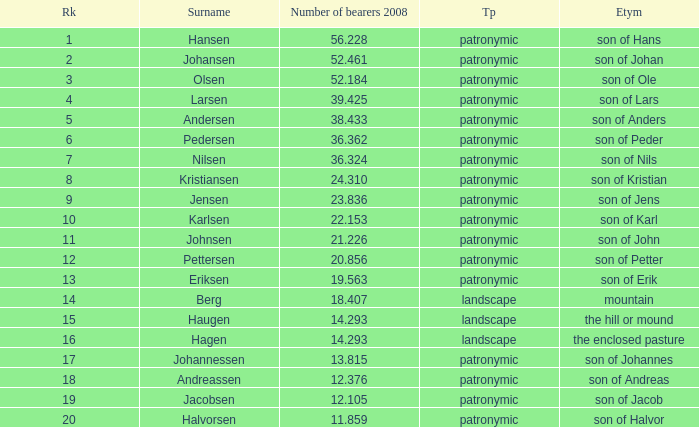What is Type, when Rank is greater than 6, when Number of Bearers 2008 is greater than 13.815, and when Surname is Eriksen? Patronymic. 